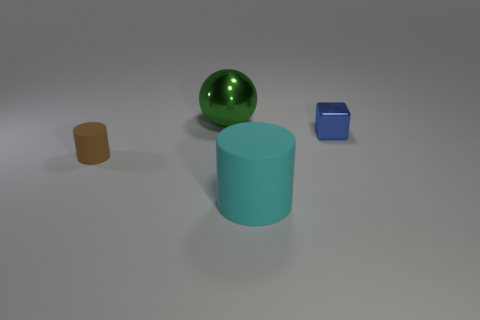Add 2 red blocks. How many objects exist? 6 Subtract 1 blocks. How many blocks are left? 0 Subtract all blocks. How many objects are left? 3 Subtract all brown cylinders. How many cylinders are left? 1 Subtract 0 gray cylinders. How many objects are left? 4 Subtract all brown spheres. Subtract all red cylinders. How many spheres are left? 1 Subtract all green cubes. How many cyan spheres are left? 0 Subtract all big cyan cylinders. Subtract all large objects. How many objects are left? 1 Add 1 tiny shiny things. How many tiny shiny things are left? 2 Add 2 cyan rubber cylinders. How many cyan rubber cylinders exist? 3 